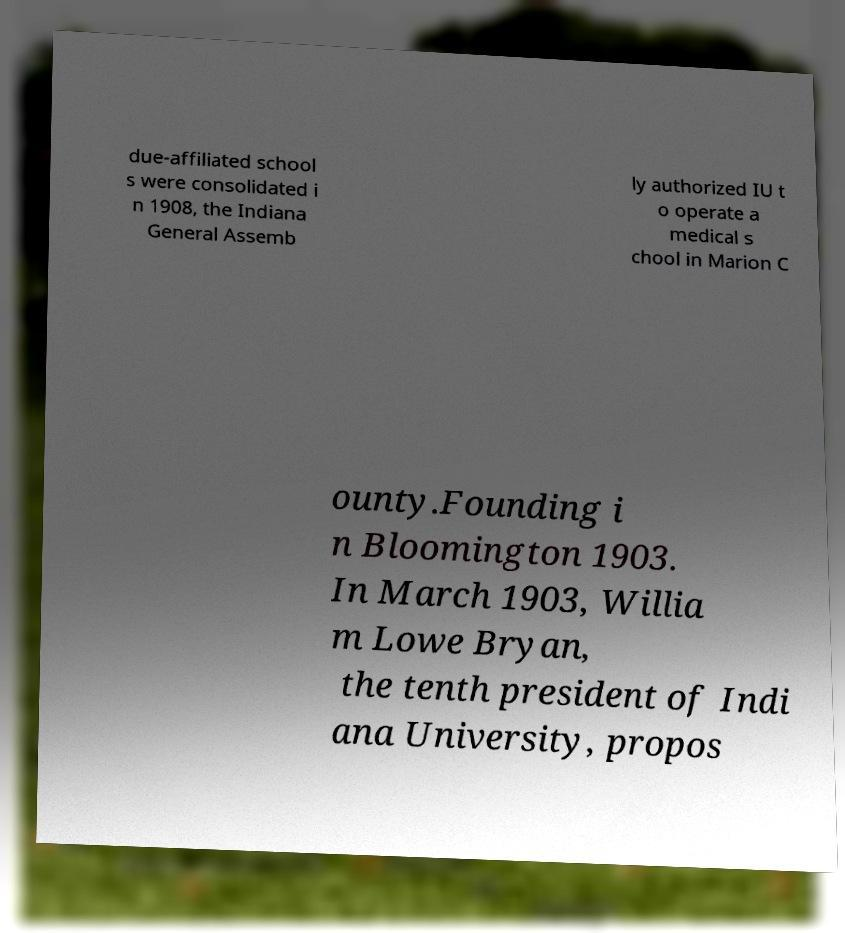For documentation purposes, I need the text within this image transcribed. Could you provide that? due-affiliated school s were consolidated i n 1908, the Indiana General Assemb ly authorized IU t o operate a medical s chool in Marion C ounty.Founding i n Bloomington 1903. In March 1903, Willia m Lowe Bryan, the tenth president of Indi ana University, propos 